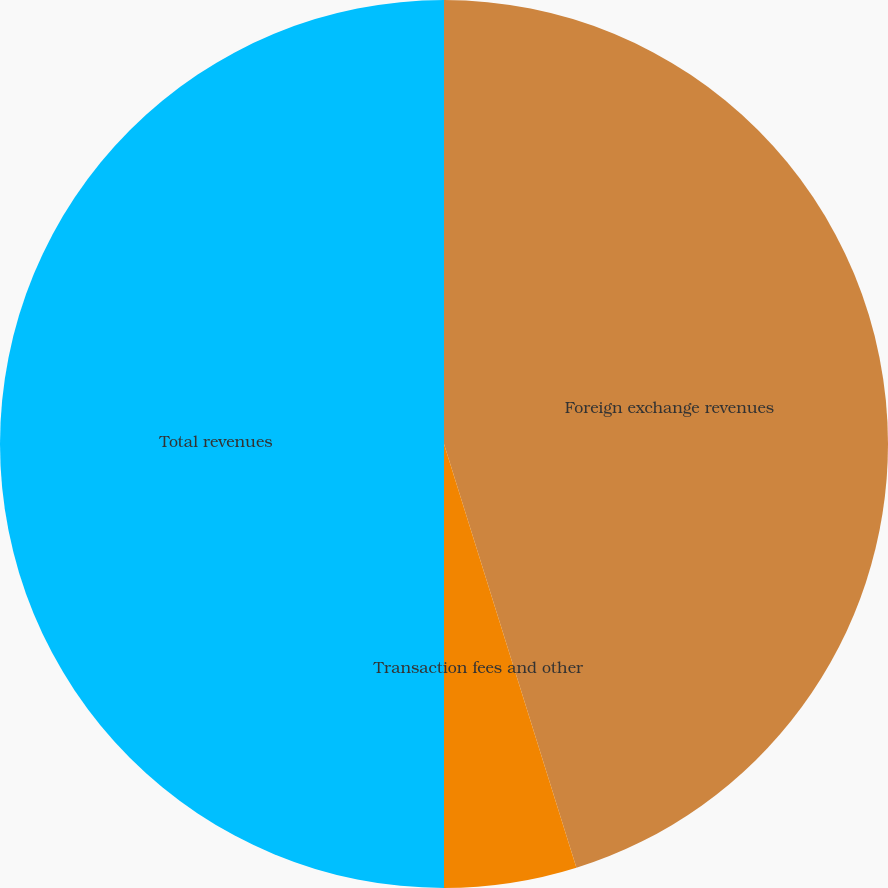Convert chart to OTSL. <chart><loc_0><loc_0><loc_500><loc_500><pie_chart><fcel>Foreign exchange revenues<fcel>Transaction fees and other<fcel>Total revenues<nl><fcel>45.18%<fcel>4.82%<fcel>50.0%<nl></chart> 